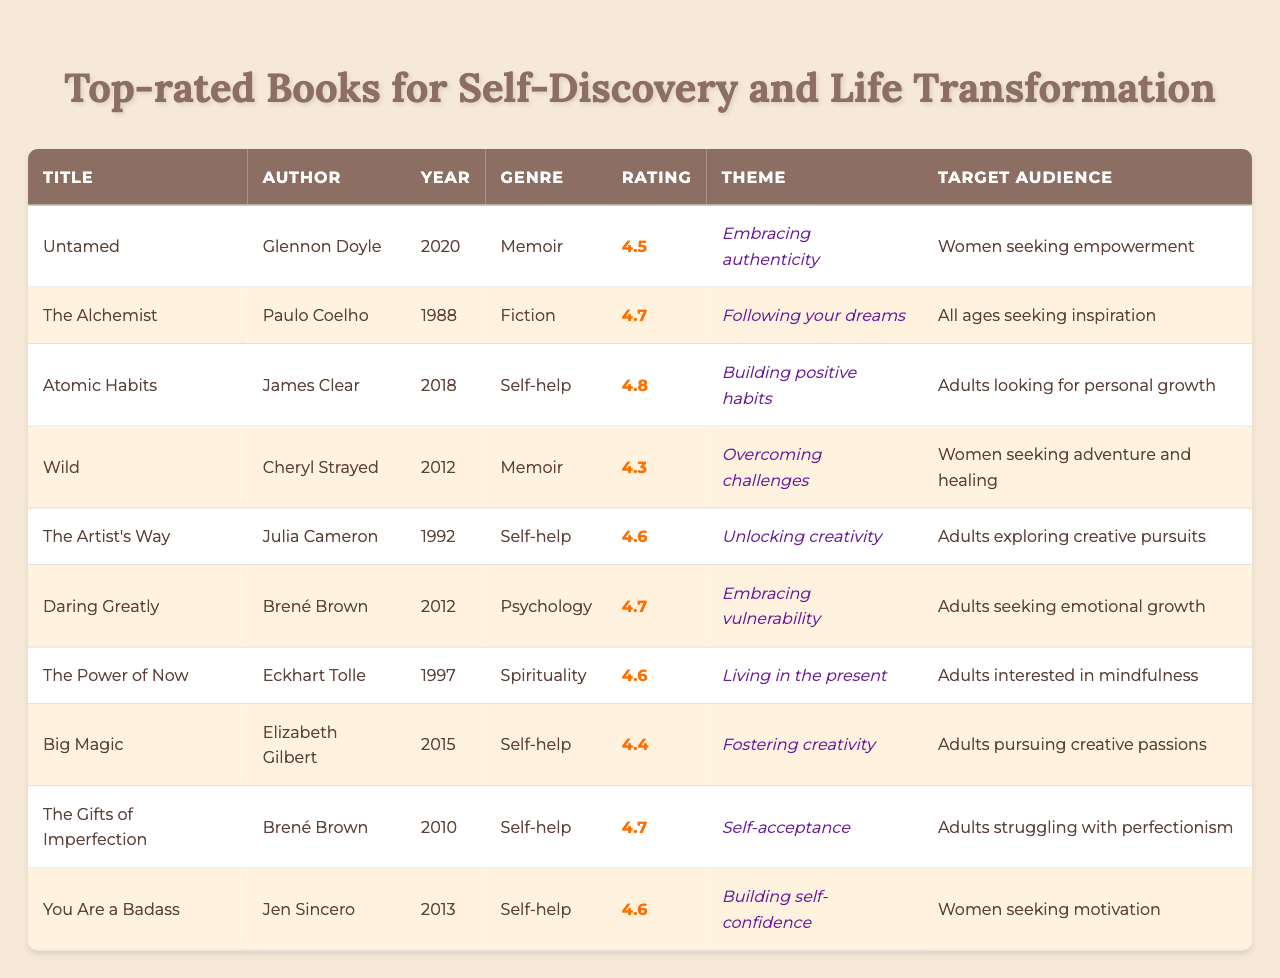What is the highest-rated book in the table? The highest rating in the table is 4.8, which corresponds to the book "Atomic Habits" by James Clear.
Answer: Atomic Habits Who is the author of "The Gifts of Imperfection"? "The Gifts of Imperfection" is authored by Brené Brown, as indicated in the table.
Answer: Brené Brown How many books are rated 4.7 or higher? There are six books with ratings of 4.7 or higher: "The Alchemist," "Atomic Habits," "Daring Greatly," "The Gifts of Imperfection," "You Are a Badass," and "The Power of Now."
Answer: 6 What is the genre of the book with the theme "Embracing authenticity"? The book with the theme "Embracing authenticity" is "Untamed," and its genre is Memoir.
Answer: Memoir Are there any books aimed specifically at women in the target audience? Yes, there are three books specifically aimed at women in the target audience: "Untamed," "Wild," and "You Are a Badass."
Answer: Yes What is the average rating of the self-help genre books? The ratings for self-help books are 4.8 (Atomic Habits), 4.6 (The Artist's Way), 4.7 (The Gifts of Imperfection), and 4.6 (You Are a Badass). The average rating is (4.8 + 4.6 + 4.7 + 4.6) / 4 = 4.675.
Answer: 4.675 Which book has the theme of "Living in the present"? "The Power of Now" has the theme of "Living in the present," as shown in the table.
Answer: The Power of Now Is "Wild" rated higher than "Big Magic"? "Wild" is rated 4.3, while "Big Magic" is rated 4.4, which means "Wild" is rated lower than "Big Magic."
Answer: No What is the difference in rating between "The Alchemist" and "Untamed"? "The Alchemist" is rated 4.7, while "Untamed" is rated 4.5. The difference in their ratings is 4.7 - 4.5 = 0.2.
Answer: 0.2 What percentage of the books are memoirs? There are 2 memoirs ("Untamed" and "Wild") out of a total of 10 books. The percentage is (2 / 10) * 100 = 20%.
Answer: 20% 